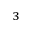<formula> <loc_0><loc_0><loc_500><loc_500>_ { 3 }</formula> 